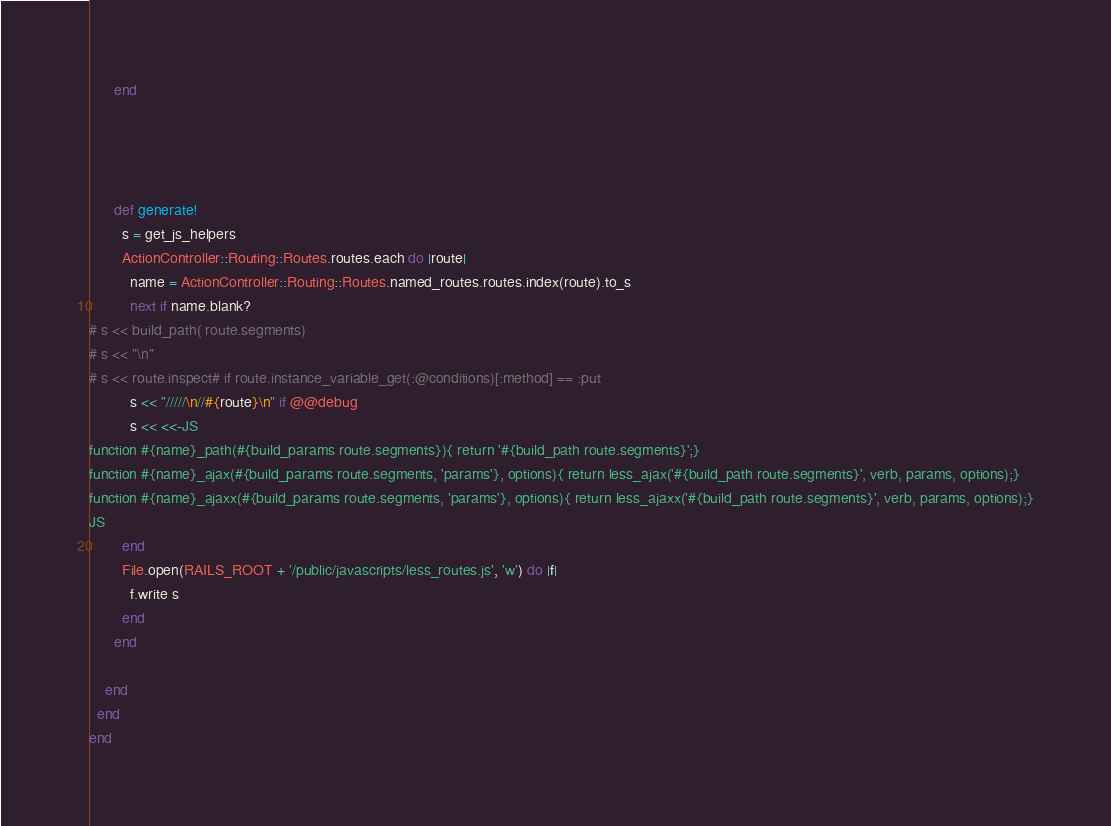<code> <loc_0><loc_0><loc_500><loc_500><_Ruby_>      end




      def generate!
        s = get_js_helpers
        ActionController::Routing::Routes.routes.each do |route|
          name = ActionController::Routing::Routes.named_routes.routes.index(route).to_s
          next if name.blank?
# s << build_path( route.segments)
# s << "\n"
# s << route.inspect# if route.instance_variable_get(:@conditions)[:method] == :put
          s << "/////\n//#{route}\n" if @@debug
          s << <<-JS
function #{name}_path(#{build_params route.segments}){ return '#{build_path route.segments}';}
function #{name}_ajax(#{build_params route.segments, 'params'}, options){ return less_ajax('#{build_path route.segments}', verb, params, options);}
function #{name}_ajaxx(#{build_params route.segments, 'params'}, options){ return less_ajaxx('#{build_path route.segments}', verb, params, options);}
JS
        end
        File.open(RAILS_ROOT + '/public/javascripts/less_routes.js', 'w') do |f|
          f.write s
        end
      end

    end
  end
end
</code> 